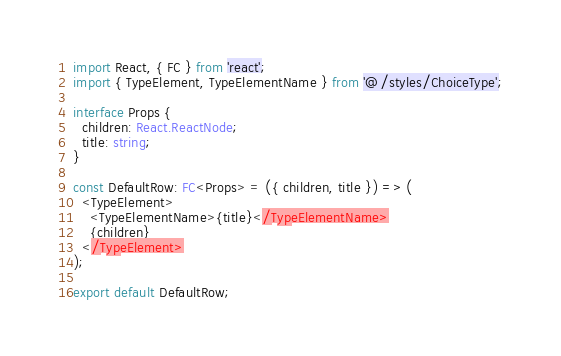Convert code to text. <code><loc_0><loc_0><loc_500><loc_500><_TypeScript_>import React, { FC } from 'react';
import { TypeElement, TypeElementName } from '@/styles/ChoiceType';

interface Props {
  children: React.ReactNode;
  title: string;
}

const DefaultRow: FC<Props> = ({ children, title }) => (
  <TypeElement>
    <TypeElementName>{title}</TypeElementName>
    {children}
  </TypeElement>
);

export default DefaultRow;
</code> 